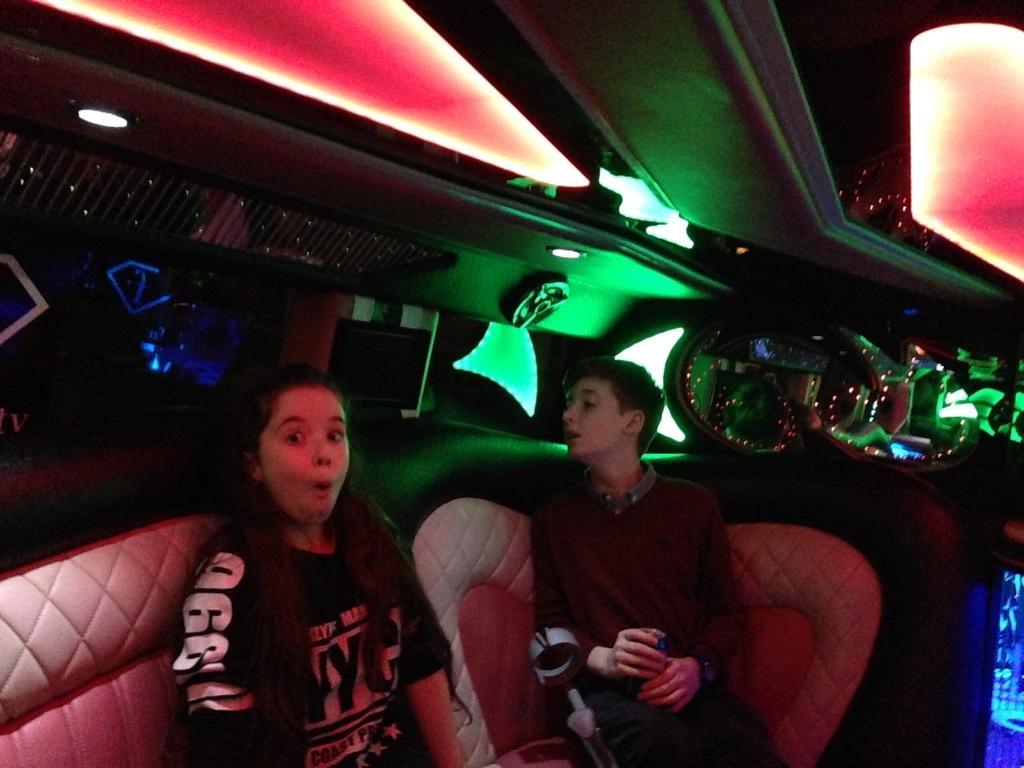Can you describe this image briefly? In this picture I can observe two members. One of them is a girl and the other one is a boy sitting in the sofas. In the background I can observe green, red and blue color lights. 